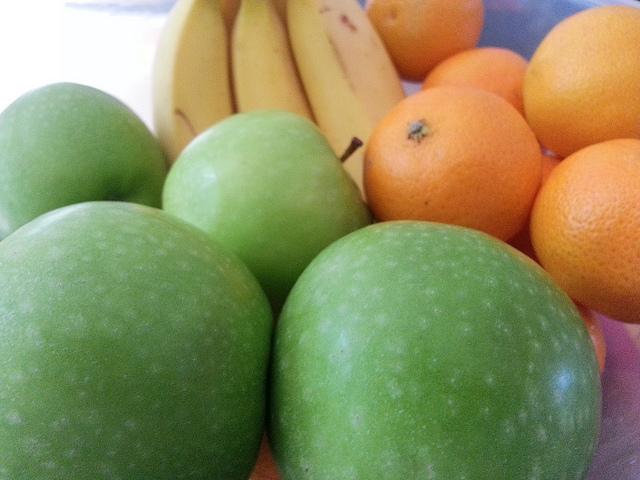How many apples are there?
Quick response, please. 4. What types of fruit are in the picture?
Give a very brief answer. Apples, oranges, bananas. Does all of the food in the picture look like it would be healthy to eat?
Concise answer only. Yes. 